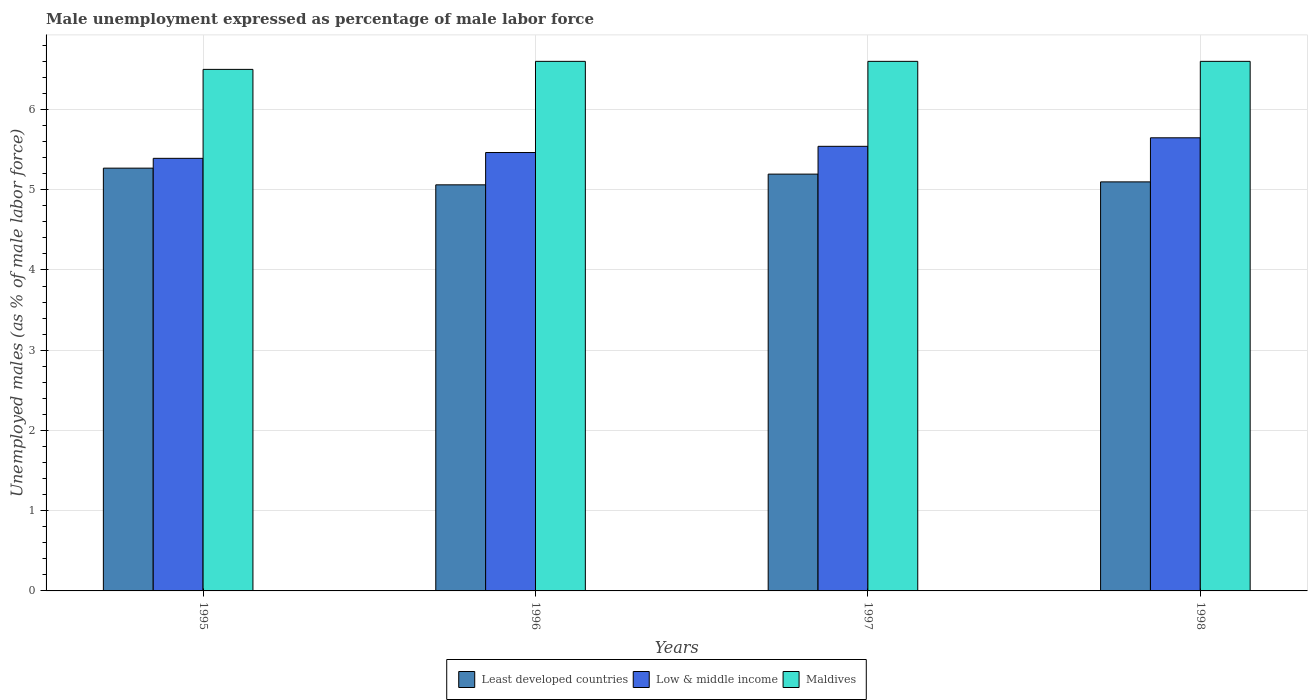How many groups of bars are there?
Provide a succinct answer. 4. Are the number of bars per tick equal to the number of legend labels?
Ensure brevity in your answer.  Yes. How many bars are there on the 1st tick from the right?
Ensure brevity in your answer.  3. In how many cases, is the number of bars for a given year not equal to the number of legend labels?
Give a very brief answer. 0. What is the unemployment in males in in Least developed countries in 1996?
Give a very brief answer. 5.06. Across all years, what is the maximum unemployment in males in in Low & middle income?
Keep it short and to the point. 5.65. Across all years, what is the minimum unemployment in males in in Least developed countries?
Offer a terse response. 5.06. In which year was the unemployment in males in in Least developed countries minimum?
Offer a terse response. 1996. What is the total unemployment in males in in Maldives in the graph?
Your answer should be very brief. 26.3. What is the difference between the unemployment in males in in Low & middle income in 1998 and the unemployment in males in in Maldives in 1996?
Give a very brief answer. -0.95. What is the average unemployment in males in in Low & middle income per year?
Ensure brevity in your answer.  5.51. In the year 1997, what is the difference between the unemployment in males in in Low & middle income and unemployment in males in in Maldives?
Your response must be concise. -1.06. What is the ratio of the unemployment in males in in Least developed countries in 1995 to that in 1998?
Your answer should be very brief. 1.03. Is the unemployment in males in in Least developed countries in 1995 less than that in 1996?
Offer a terse response. No. What is the difference between the highest and the second highest unemployment in males in in Least developed countries?
Provide a short and direct response. 0.07. What is the difference between the highest and the lowest unemployment in males in in Low & middle income?
Offer a very short reply. 0.26. In how many years, is the unemployment in males in in Least developed countries greater than the average unemployment in males in in Least developed countries taken over all years?
Your answer should be very brief. 2. Is the sum of the unemployment in males in in Maldives in 1996 and 1997 greater than the maximum unemployment in males in in Low & middle income across all years?
Your answer should be compact. Yes. What does the 2nd bar from the left in 1998 represents?
Give a very brief answer. Low & middle income. What does the 1st bar from the right in 1997 represents?
Your answer should be compact. Maldives. Is it the case that in every year, the sum of the unemployment in males in in Maldives and unemployment in males in in Least developed countries is greater than the unemployment in males in in Low & middle income?
Make the answer very short. Yes. How many bars are there?
Give a very brief answer. 12. Are the values on the major ticks of Y-axis written in scientific E-notation?
Offer a very short reply. No. Does the graph contain any zero values?
Your answer should be compact. No. Where does the legend appear in the graph?
Your response must be concise. Bottom center. How many legend labels are there?
Offer a very short reply. 3. What is the title of the graph?
Ensure brevity in your answer.  Male unemployment expressed as percentage of male labor force. Does "Guyana" appear as one of the legend labels in the graph?
Keep it short and to the point. No. What is the label or title of the Y-axis?
Keep it short and to the point. Unemployed males (as % of male labor force). What is the Unemployed males (as % of male labor force) in Least developed countries in 1995?
Your answer should be compact. 5.27. What is the Unemployed males (as % of male labor force) of Low & middle income in 1995?
Offer a terse response. 5.39. What is the Unemployed males (as % of male labor force) of Least developed countries in 1996?
Provide a short and direct response. 5.06. What is the Unemployed males (as % of male labor force) of Low & middle income in 1996?
Make the answer very short. 5.46. What is the Unemployed males (as % of male labor force) in Maldives in 1996?
Your response must be concise. 6.6. What is the Unemployed males (as % of male labor force) of Least developed countries in 1997?
Keep it short and to the point. 5.19. What is the Unemployed males (as % of male labor force) in Low & middle income in 1997?
Provide a succinct answer. 5.54. What is the Unemployed males (as % of male labor force) of Maldives in 1997?
Offer a very short reply. 6.6. What is the Unemployed males (as % of male labor force) of Least developed countries in 1998?
Keep it short and to the point. 5.1. What is the Unemployed males (as % of male labor force) in Low & middle income in 1998?
Ensure brevity in your answer.  5.65. What is the Unemployed males (as % of male labor force) in Maldives in 1998?
Provide a short and direct response. 6.6. Across all years, what is the maximum Unemployed males (as % of male labor force) in Least developed countries?
Provide a short and direct response. 5.27. Across all years, what is the maximum Unemployed males (as % of male labor force) of Low & middle income?
Keep it short and to the point. 5.65. Across all years, what is the maximum Unemployed males (as % of male labor force) of Maldives?
Keep it short and to the point. 6.6. Across all years, what is the minimum Unemployed males (as % of male labor force) in Least developed countries?
Offer a very short reply. 5.06. Across all years, what is the minimum Unemployed males (as % of male labor force) of Low & middle income?
Provide a short and direct response. 5.39. What is the total Unemployed males (as % of male labor force) of Least developed countries in the graph?
Provide a succinct answer. 20.62. What is the total Unemployed males (as % of male labor force) in Low & middle income in the graph?
Provide a succinct answer. 22.04. What is the total Unemployed males (as % of male labor force) in Maldives in the graph?
Offer a very short reply. 26.3. What is the difference between the Unemployed males (as % of male labor force) of Least developed countries in 1995 and that in 1996?
Make the answer very short. 0.21. What is the difference between the Unemployed males (as % of male labor force) of Low & middle income in 1995 and that in 1996?
Offer a terse response. -0.07. What is the difference between the Unemployed males (as % of male labor force) of Maldives in 1995 and that in 1996?
Keep it short and to the point. -0.1. What is the difference between the Unemployed males (as % of male labor force) in Least developed countries in 1995 and that in 1997?
Offer a very short reply. 0.07. What is the difference between the Unemployed males (as % of male labor force) of Low & middle income in 1995 and that in 1997?
Ensure brevity in your answer.  -0.15. What is the difference between the Unemployed males (as % of male labor force) in Least developed countries in 1995 and that in 1998?
Make the answer very short. 0.17. What is the difference between the Unemployed males (as % of male labor force) in Low & middle income in 1995 and that in 1998?
Provide a succinct answer. -0.26. What is the difference between the Unemployed males (as % of male labor force) in Maldives in 1995 and that in 1998?
Offer a terse response. -0.1. What is the difference between the Unemployed males (as % of male labor force) of Least developed countries in 1996 and that in 1997?
Your response must be concise. -0.13. What is the difference between the Unemployed males (as % of male labor force) of Low & middle income in 1996 and that in 1997?
Offer a very short reply. -0.08. What is the difference between the Unemployed males (as % of male labor force) of Least developed countries in 1996 and that in 1998?
Your answer should be very brief. -0.04. What is the difference between the Unemployed males (as % of male labor force) of Low & middle income in 1996 and that in 1998?
Ensure brevity in your answer.  -0.18. What is the difference between the Unemployed males (as % of male labor force) of Maldives in 1996 and that in 1998?
Offer a terse response. 0. What is the difference between the Unemployed males (as % of male labor force) in Least developed countries in 1997 and that in 1998?
Make the answer very short. 0.1. What is the difference between the Unemployed males (as % of male labor force) of Low & middle income in 1997 and that in 1998?
Offer a very short reply. -0.11. What is the difference between the Unemployed males (as % of male labor force) of Maldives in 1997 and that in 1998?
Make the answer very short. 0. What is the difference between the Unemployed males (as % of male labor force) of Least developed countries in 1995 and the Unemployed males (as % of male labor force) of Low & middle income in 1996?
Ensure brevity in your answer.  -0.19. What is the difference between the Unemployed males (as % of male labor force) in Least developed countries in 1995 and the Unemployed males (as % of male labor force) in Maldives in 1996?
Your response must be concise. -1.33. What is the difference between the Unemployed males (as % of male labor force) of Low & middle income in 1995 and the Unemployed males (as % of male labor force) of Maldives in 1996?
Ensure brevity in your answer.  -1.21. What is the difference between the Unemployed males (as % of male labor force) of Least developed countries in 1995 and the Unemployed males (as % of male labor force) of Low & middle income in 1997?
Give a very brief answer. -0.27. What is the difference between the Unemployed males (as % of male labor force) in Least developed countries in 1995 and the Unemployed males (as % of male labor force) in Maldives in 1997?
Give a very brief answer. -1.33. What is the difference between the Unemployed males (as % of male labor force) of Low & middle income in 1995 and the Unemployed males (as % of male labor force) of Maldives in 1997?
Provide a succinct answer. -1.21. What is the difference between the Unemployed males (as % of male labor force) of Least developed countries in 1995 and the Unemployed males (as % of male labor force) of Low & middle income in 1998?
Provide a short and direct response. -0.38. What is the difference between the Unemployed males (as % of male labor force) of Least developed countries in 1995 and the Unemployed males (as % of male labor force) of Maldives in 1998?
Your response must be concise. -1.33. What is the difference between the Unemployed males (as % of male labor force) of Low & middle income in 1995 and the Unemployed males (as % of male labor force) of Maldives in 1998?
Your answer should be compact. -1.21. What is the difference between the Unemployed males (as % of male labor force) in Least developed countries in 1996 and the Unemployed males (as % of male labor force) in Low & middle income in 1997?
Your response must be concise. -0.48. What is the difference between the Unemployed males (as % of male labor force) of Least developed countries in 1996 and the Unemployed males (as % of male labor force) of Maldives in 1997?
Provide a succinct answer. -1.54. What is the difference between the Unemployed males (as % of male labor force) in Low & middle income in 1996 and the Unemployed males (as % of male labor force) in Maldives in 1997?
Provide a succinct answer. -1.14. What is the difference between the Unemployed males (as % of male labor force) in Least developed countries in 1996 and the Unemployed males (as % of male labor force) in Low & middle income in 1998?
Ensure brevity in your answer.  -0.59. What is the difference between the Unemployed males (as % of male labor force) of Least developed countries in 1996 and the Unemployed males (as % of male labor force) of Maldives in 1998?
Your response must be concise. -1.54. What is the difference between the Unemployed males (as % of male labor force) in Low & middle income in 1996 and the Unemployed males (as % of male labor force) in Maldives in 1998?
Keep it short and to the point. -1.14. What is the difference between the Unemployed males (as % of male labor force) of Least developed countries in 1997 and the Unemployed males (as % of male labor force) of Low & middle income in 1998?
Keep it short and to the point. -0.45. What is the difference between the Unemployed males (as % of male labor force) in Least developed countries in 1997 and the Unemployed males (as % of male labor force) in Maldives in 1998?
Your answer should be compact. -1.41. What is the difference between the Unemployed males (as % of male labor force) of Low & middle income in 1997 and the Unemployed males (as % of male labor force) of Maldives in 1998?
Ensure brevity in your answer.  -1.06. What is the average Unemployed males (as % of male labor force) of Least developed countries per year?
Provide a short and direct response. 5.16. What is the average Unemployed males (as % of male labor force) of Low & middle income per year?
Keep it short and to the point. 5.51. What is the average Unemployed males (as % of male labor force) in Maldives per year?
Give a very brief answer. 6.58. In the year 1995, what is the difference between the Unemployed males (as % of male labor force) of Least developed countries and Unemployed males (as % of male labor force) of Low & middle income?
Make the answer very short. -0.12. In the year 1995, what is the difference between the Unemployed males (as % of male labor force) in Least developed countries and Unemployed males (as % of male labor force) in Maldives?
Your response must be concise. -1.23. In the year 1995, what is the difference between the Unemployed males (as % of male labor force) of Low & middle income and Unemployed males (as % of male labor force) of Maldives?
Your answer should be compact. -1.11. In the year 1996, what is the difference between the Unemployed males (as % of male labor force) of Least developed countries and Unemployed males (as % of male labor force) of Low & middle income?
Provide a short and direct response. -0.4. In the year 1996, what is the difference between the Unemployed males (as % of male labor force) of Least developed countries and Unemployed males (as % of male labor force) of Maldives?
Your response must be concise. -1.54. In the year 1996, what is the difference between the Unemployed males (as % of male labor force) of Low & middle income and Unemployed males (as % of male labor force) of Maldives?
Provide a succinct answer. -1.14. In the year 1997, what is the difference between the Unemployed males (as % of male labor force) in Least developed countries and Unemployed males (as % of male labor force) in Low & middle income?
Provide a short and direct response. -0.35. In the year 1997, what is the difference between the Unemployed males (as % of male labor force) in Least developed countries and Unemployed males (as % of male labor force) in Maldives?
Make the answer very short. -1.41. In the year 1997, what is the difference between the Unemployed males (as % of male labor force) in Low & middle income and Unemployed males (as % of male labor force) in Maldives?
Make the answer very short. -1.06. In the year 1998, what is the difference between the Unemployed males (as % of male labor force) in Least developed countries and Unemployed males (as % of male labor force) in Low & middle income?
Provide a short and direct response. -0.55. In the year 1998, what is the difference between the Unemployed males (as % of male labor force) of Least developed countries and Unemployed males (as % of male labor force) of Maldives?
Provide a short and direct response. -1.5. In the year 1998, what is the difference between the Unemployed males (as % of male labor force) of Low & middle income and Unemployed males (as % of male labor force) of Maldives?
Make the answer very short. -0.95. What is the ratio of the Unemployed males (as % of male labor force) of Least developed countries in 1995 to that in 1996?
Make the answer very short. 1.04. What is the ratio of the Unemployed males (as % of male labor force) in Low & middle income in 1995 to that in 1996?
Give a very brief answer. 0.99. What is the ratio of the Unemployed males (as % of male labor force) of Maldives in 1995 to that in 1996?
Your answer should be compact. 0.98. What is the ratio of the Unemployed males (as % of male labor force) of Least developed countries in 1995 to that in 1997?
Your response must be concise. 1.01. What is the ratio of the Unemployed males (as % of male labor force) in Low & middle income in 1995 to that in 1997?
Your answer should be very brief. 0.97. What is the ratio of the Unemployed males (as % of male labor force) of Least developed countries in 1995 to that in 1998?
Give a very brief answer. 1.03. What is the ratio of the Unemployed males (as % of male labor force) in Low & middle income in 1995 to that in 1998?
Your response must be concise. 0.95. What is the ratio of the Unemployed males (as % of male labor force) of Least developed countries in 1996 to that in 1997?
Give a very brief answer. 0.97. What is the ratio of the Unemployed males (as % of male labor force) in Low & middle income in 1996 to that in 1997?
Ensure brevity in your answer.  0.99. What is the ratio of the Unemployed males (as % of male labor force) in Maldives in 1996 to that in 1997?
Your answer should be very brief. 1. What is the ratio of the Unemployed males (as % of male labor force) of Low & middle income in 1996 to that in 1998?
Your response must be concise. 0.97. What is the ratio of the Unemployed males (as % of male labor force) in Least developed countries in 1997 to that in 1998?
Provide a short and direct response. 1.02. What is the ratio of the Unemployed males (as % of male labor force) of Low & middle income in 1997 to that in 1998?
Provide a short and direct response. 0.98. What is the difference between the highest and the second highest Unemployed males (as % of male labor force) in Least developed countries?
Ensure brevity in your answer.  0.07. What is the difference between the highest and the second highest Unemployed males (as % of male labor force) of Low & middle income?
Provide a short and direct response. 0.11. What is the difference between the highest and the second highest Unemployed males (as % of male labor force) in Maldives?
Offer a very short reply. 0. What is the difference between the highest and the lowest Unemployed males (as % of male labor force) in Least developed countries?
Provide a short and direct response. 0.21. What is the difference between the highest and the lowest Unemployed males (as % of male labor force) of Low & middle income?
Ensure brevity in your answer.  0.26. What is the difference between the highest and the lowest Unemployed males (as % of male labor force) of Maldives?
Ensure brevity in your answer.  0.1. 